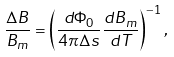Convert formula to latex. <formula><loc_0><loc_0><loc_500><loc_500>\frac { \Delta B } { B _ { m } } = \left ( \frac { d \Phi _ { 0 } } { 4 \pi \Delta s } \frac { d B _ { m } } { d T } \right ) ^ { - 1 } ,</formula> 